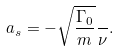Convert formula to latex. <formula><loc_0><loc_0><loc_500><loc_500>a _ { s } = - \sqrt { \frac { \Gamma _ { 0 } } { m } } \frac { } { \nu } .</formula> 